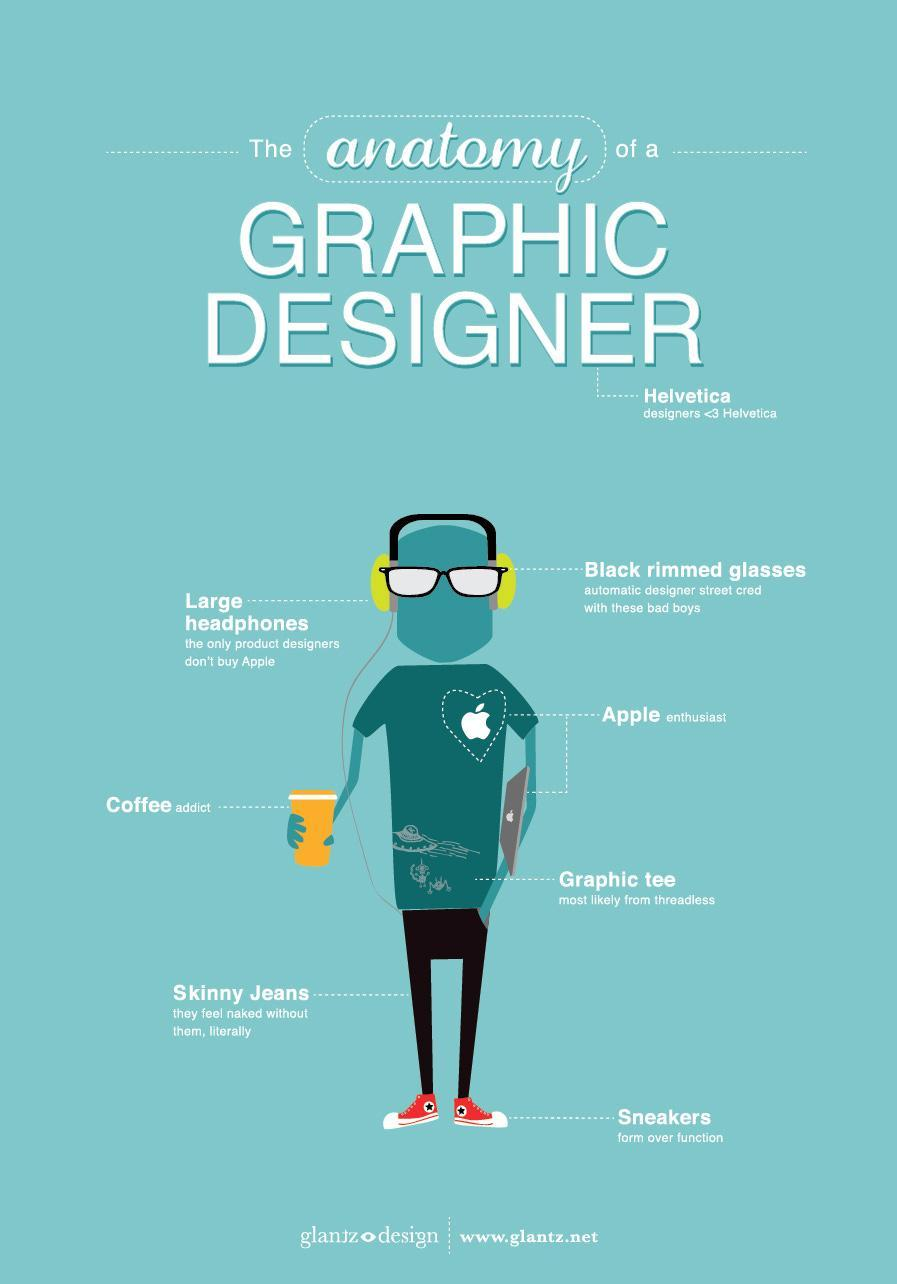What specification of glasses are more likely to be used by helvetica designers?
Answer the question with a short phrase. Black rimmed glasses What type of t-shirts a graphic designer wear usually? Graphic tee What type of shoes does a Helvetica designer prefer to wear? Sneakers Which fit in jeans does a Helvetica designer prefers? Skinny Jeans 